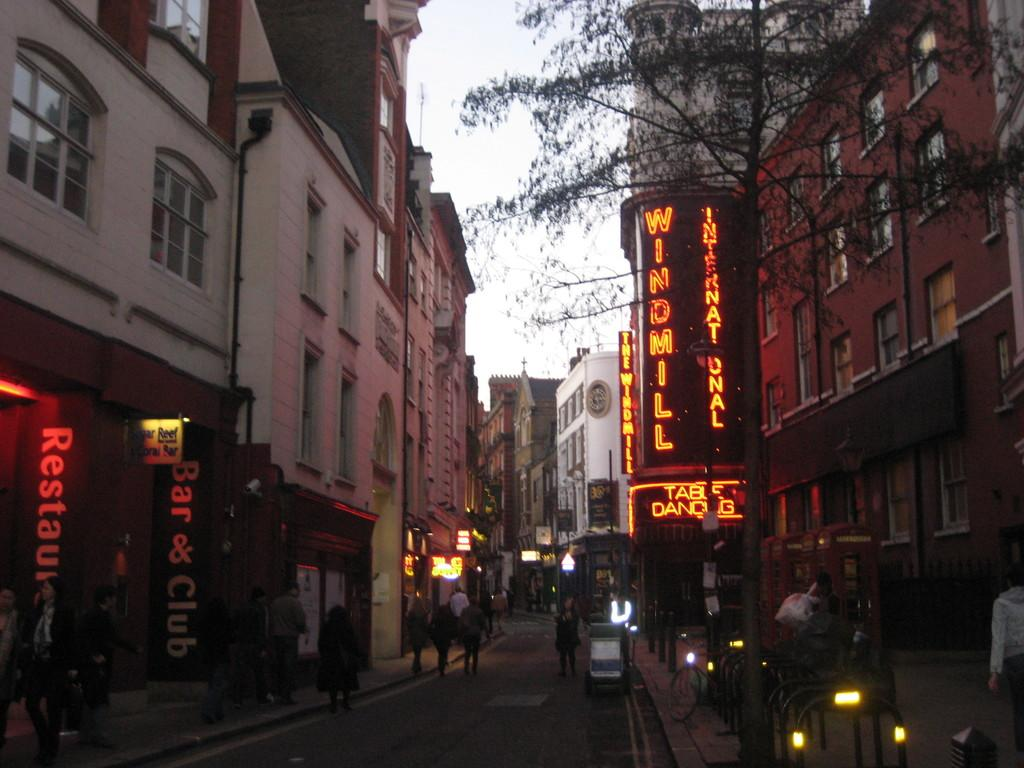What is the main subject of the image? The main subject of the image is a view of a road. What can be seen on the road? There are persons walking on the road. What is visible on both sides of the road? There are buildings, shops, and trees on both sides of the road. What type of print can be seen on the church in the image? There is no church present in the image, so it is not possible to determine what type of print might be on it. 